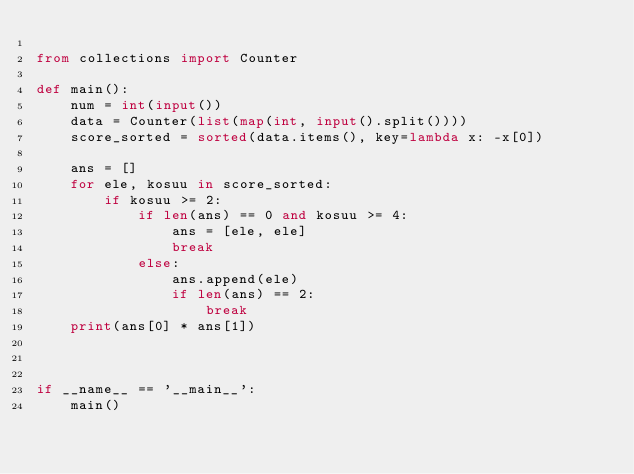Convert code to text. <code><loc_0><loc_0><loc_500><loc_500><_Python_>
from collections import Counter

def main():
    num = int(input())
    data = Counter(list(map(int, input().split())))
    score_sorted = sorted(data.items(), key=lambda x: -x[0])

    ans = []
    for ele, kosuu in score_sorted:
        if kosuu >= 2:
            if len(ans) == 0 and kosuu >= 4:
                ans = [ele, ele]
                break
            else:
                ans.append(ele)
                if len(ans) == 2:
                    break
    print(ans[0] * ans[1])



if __name__ == '__main__':
    main()


</code> 